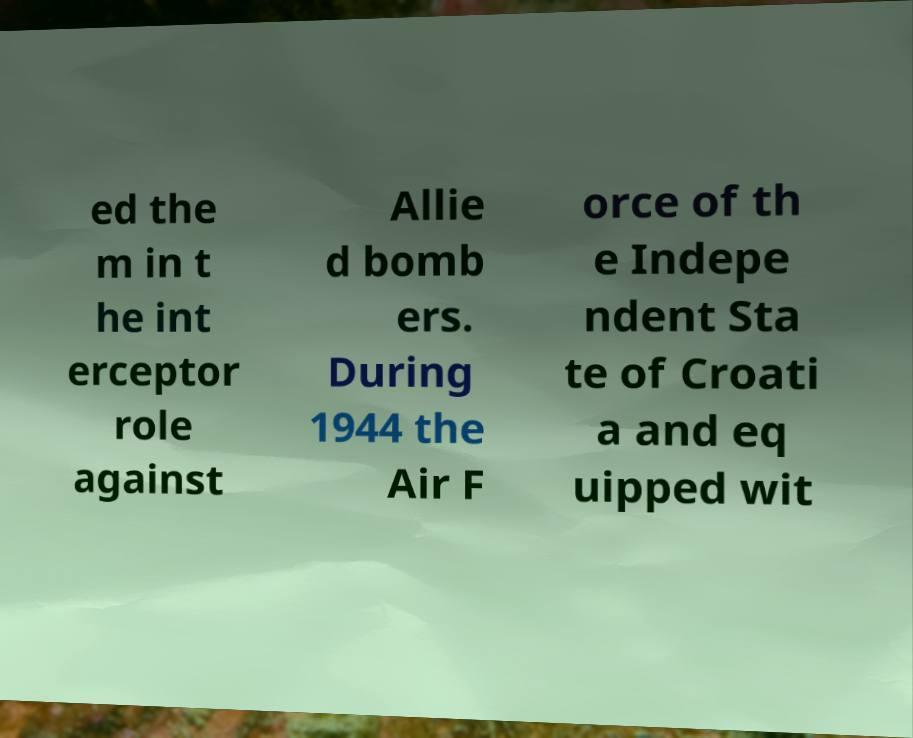I need the written content from this picture converted into text. Can you do that? ed the m in t he int erceptor role against Allie d bomb ers. During 1944 the Air F orce of th e Indepe ndent Sta te of Croati a and eq uipped wit 